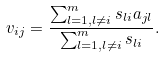Convert formula to latex. <formula><loc_0><loc_0><loc_500><loc_500>v _ { i j } = \frac { \sum ^ { m } _ { l = 1 , l \neq i } s _ { l i } a _ { j l } } { \sum ^ { m } _ { l = 1 , l \neq i } s _ { l i } } .</formula> 